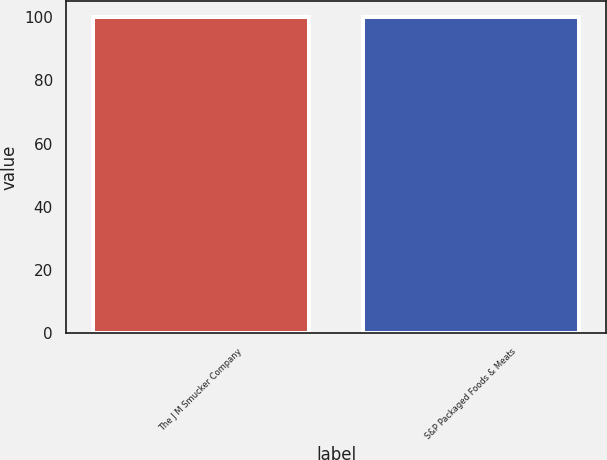Convert chart to OTSL. <chart><loc_0><loc_0><loc_500><loc_500><bar_chart><fcel>The J M Smucker Company<fcel>S&P Packaged Foods & Meats<nl><fcel>100<fcel>100.1<nl></chart> 